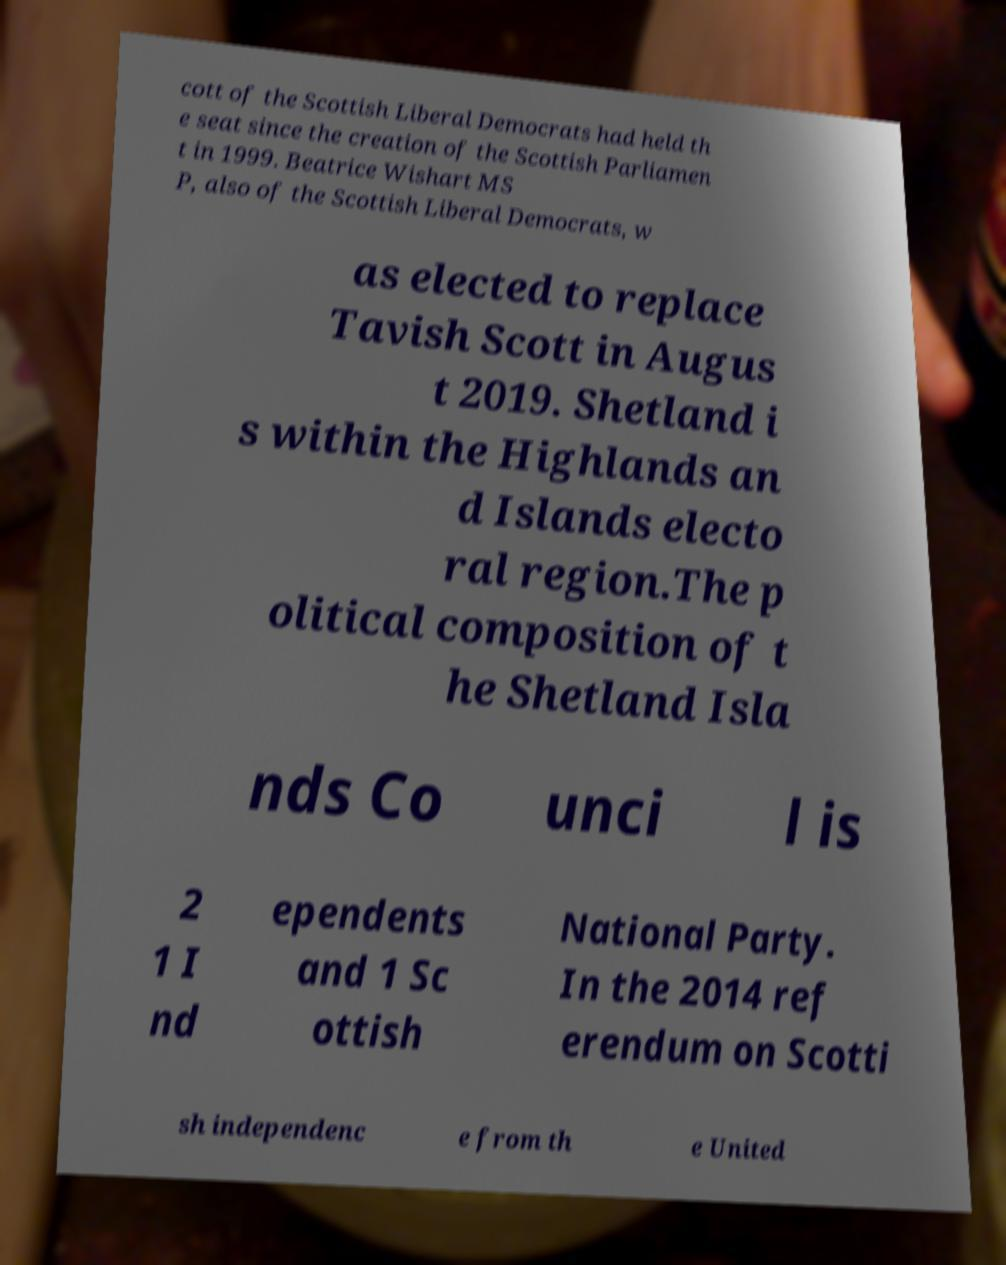There's text embedded in this image that I need extracted. Can you transcribe it verbatim? cott of the Scottish Liberal Democrats had held th e seat since the creation of the Scottish Parliamen t in 1999. Beatrice Wishart MS P, also of the Scottish Liberal Democrats, w as elected to replace Tavish Scott in Augus t 2019. Shetland i s within the Highlands an d Islands electo ral region.The p olitical composition of t he Shetland Isla nds Co unci l is 2 1 I nd ependents and 1 Sc ottish National Party. In the 2014 ref erendum on Scotti sh independenc e from th e United 